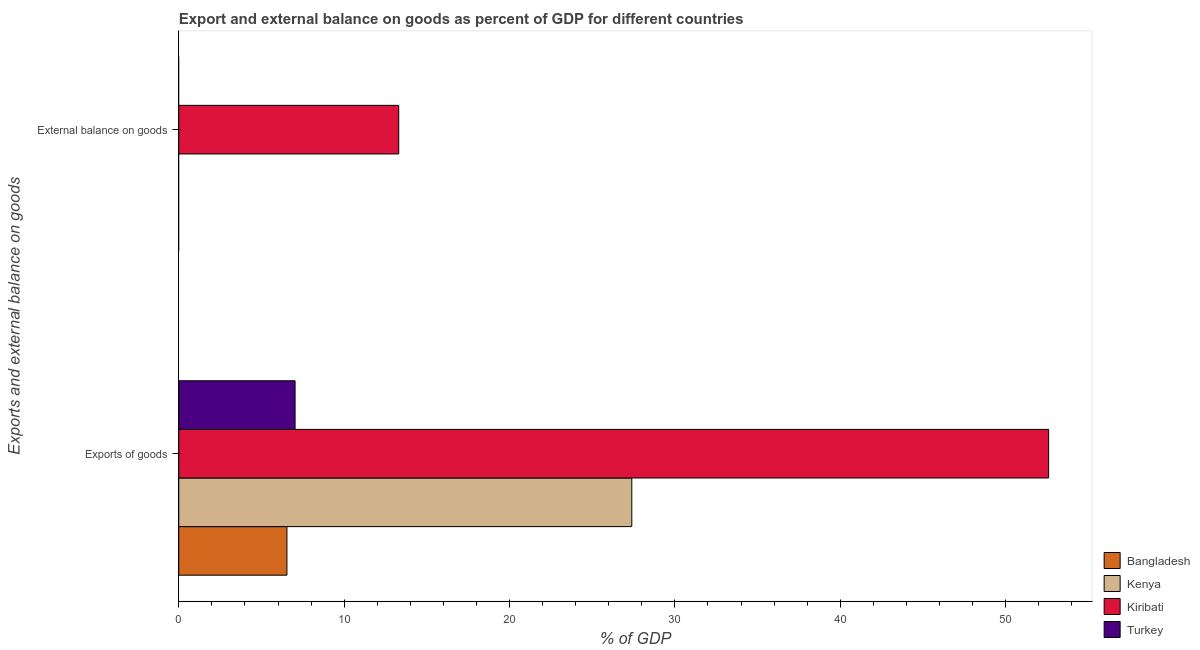Are the number of bars per tick equal to the number of legend labels?
Give a very brief answer. No. Are the number of bars on each tick of the Y-axis equal?
Make the answer very short. No. How many bars are there on the 1st tick from the bottom?
Your response must be concise. 4. What is the label of the 1st group of bars from the top?
Your answer should be very brief. External balance on goods. Across all countries, what is the maximum external balance on goods as percentage of gdp?
Give a very brief answer. 13.3. Across all countries, what is the minimum external balance on goods as percentage of gdp?
Offer a terse response. 0. In which country was the export of goods as percentage of gdp maximum?
Ensure brevity in your answer.  Kiribati. What is the total external balance on goods as percentage of gdp in the graph?
Offer a terse response. 13.3. What is the difference between the export of goods as percentage of gdp in Bangladesh and that in Turkey?
Provide a short and direct response. -0.49. What is the difference between the export of goods as percentage of gdp in Kenya and the external balance on goods as percentage of gdp in Kiribati?
Keep it short and to the point. 14.09. What is the average export of goods as percentage of gdp per country?
Provide a succinct answer. 23.39. What is the difference between the export of goods as percentage of gdp and external balance on goods as percentage of gdp in Kiribati?
Keep it short and to the point. 39.3. In how many countries, is the export of goods as percentage of gdp greater than 24 %?
Your answer should be very brief. 2. What is the ratio of the export of goods as percentage of gdp in Kenya to that in Turkey?
Provide a succinct answer. 3.9. How many bars are there?
Provide a short and direct response. 5. Are all the bars in the graph horizontal?
Give a very brief answer. Yes. How many countries are there in the graph?
Provide a succinct answer. 4. What is the difference between two consecutive major ticks on the X-axis?
Provide a succinct answer. 10. Does the graph contain any zero values?
Your response must be concise. Yes. Where does the legend appear in the graph?
Provide a succinct answer. Bottom right. How many legend labels are there?
Your answer should be compact. 4. How are the legend labels stacked?
Provide a short and direct response. Vertical. What is the title of the graph?
Keep it short and to the point. Export and external balance on goods as percent of GDP for different countries. Does "Djibouti" appear as one of the legend labels in the graph?
Give a very brief answer. No. What is the label or title of the X-axis?
Ensure brevity in your answer.  % of GDP. What is the label or title of the Y-axis?
Your answer should be compact. Exports and external balance on goods. What is the % of GDP in Bangladesh in Exports of goods?
Offer a very short reply. 6.54. What is the % of GDP in Kenya in Exports of goods?
Keep it short and to the point. 27.39. What is the % of GDP of Kiribati in Exports of goods?
Your answer should be compact. 52.6. What is the % of GDP of Turkey in Exports of goods?
Your answer should be very brief. 7.03. What is the % of GDP of Kiribati in External balance on goods?
Offer a very short reply. 13.3. What is the % of GDP of Turkey in External balance on goods?
Your answer should be very brief. 0. Across all Exports and external balance on goods, what is the maximum % of GDP of Bangladesh?
Give a very brief answer. 6.54. Across all Exports and external balance on goods, what is the maximum % of GDP of Kenya?
Provide a short and direct response. 27.39. Across all Exports and external balance on goods, what is the maximum % of GDP in Kiribati?
Offer a very short reply. 52.6. Across all Exports and external balance on goods, what is the maximum % of GDP of Turkey?
Your answer should be compact. 7.03. Across all Exports and external balance on goods, what is the minimum % of GDP in Kiribati?
Your answer should be compact. 13.3. What is the total % of GDP in Bangladesh in the graph?
Your response must be concise. 6.54. What is the total % of GDP of Kenya in the graph?
Make the answer very short. 27.39. What is the total % of GDP in Kiribati in the graph?
Keep it short and to the point. 65.9. What is the total % of GDP of Turkey in the graph?
Provide a succinct answer. 7.03. What is the difference between the % of GDP in Kiribati in Exports of goods and that in External balance on goods?
Provide a short and direct response. 39.3. What is the difference between the % of GDP in Bangladesh in Exports of goods and the % of GDP in Kiribati in External balance on goods?
Your answer should be compact. -6.76. What is the difference between the % of GDP of Kenya in Exports of goods and the % of GDP of Kiribati in External balance on goods?
Your answer should be very brief. 14.09. What is the average % of GDP of Bangladesh per Exports and external balance on goods?
Offer a terse response. 3.27. What is the average % of GDP in Kenya per Exports and external balance on goods?
Provide a short and direct response. 13.7. What is the average % of GDP of Kiribati per Exports and external balance on goods?
Your answer should be compact. 32.95. What is the average % of GDP of Turkey per Exports and external balance on goods?
Make the answer very short. 3.52. What is the difference between the % of GDP of Bangladesh and % of GDP of Kenya in Exports of goods?
Ensure brevity in your answer.  -20.85. What is the difference between the % of GDP in Bangladesh and % of GDP in Kiribati in Exports of goods?
Your answer should be very brief. -46.06. What is the difference between the % of GDP in Bangladesh and % of GDP in Turkey in Exports of goods?
Your answer should be compact. -0.49. What is the difference between the % of GDP in Kenya and % of GDP in Kiribati in Exports of goods?
Your response must be concise. -25.21. What is the difference between the % of GDP of Kenya and % of GDP of Turkey in Exports of goods?
Provide a short and direct response. 20.36. What is the difference between the % of GDP of Kiribati and % of GDP of Turkey in Exports of goods?
Your answer should be very brief. 45.57. What is the ratio of the % of GDP in Kiribati in Exports of goods to that in External balance on goods?
Offer a terse response. 3.96. What is the difference between the highest and the second highest % of GDP of Kiribati?
Your response must be concise. 39.3. What is the difference between the highest and the lowest % of GDP of Bangladesh?
Give a very brief answer. 6.54. What is the difference between the highest and the lowest % of GDP of Kenya?
Provide a succinct answer. 27.39. What is the difference between the highest and the lowest % of GDP in Kiribati?
Offer a very short reply. 39.3. What is the difference between the highest and the lowest % of GDP in Turkey?
Your response must be concise. 7.03. 